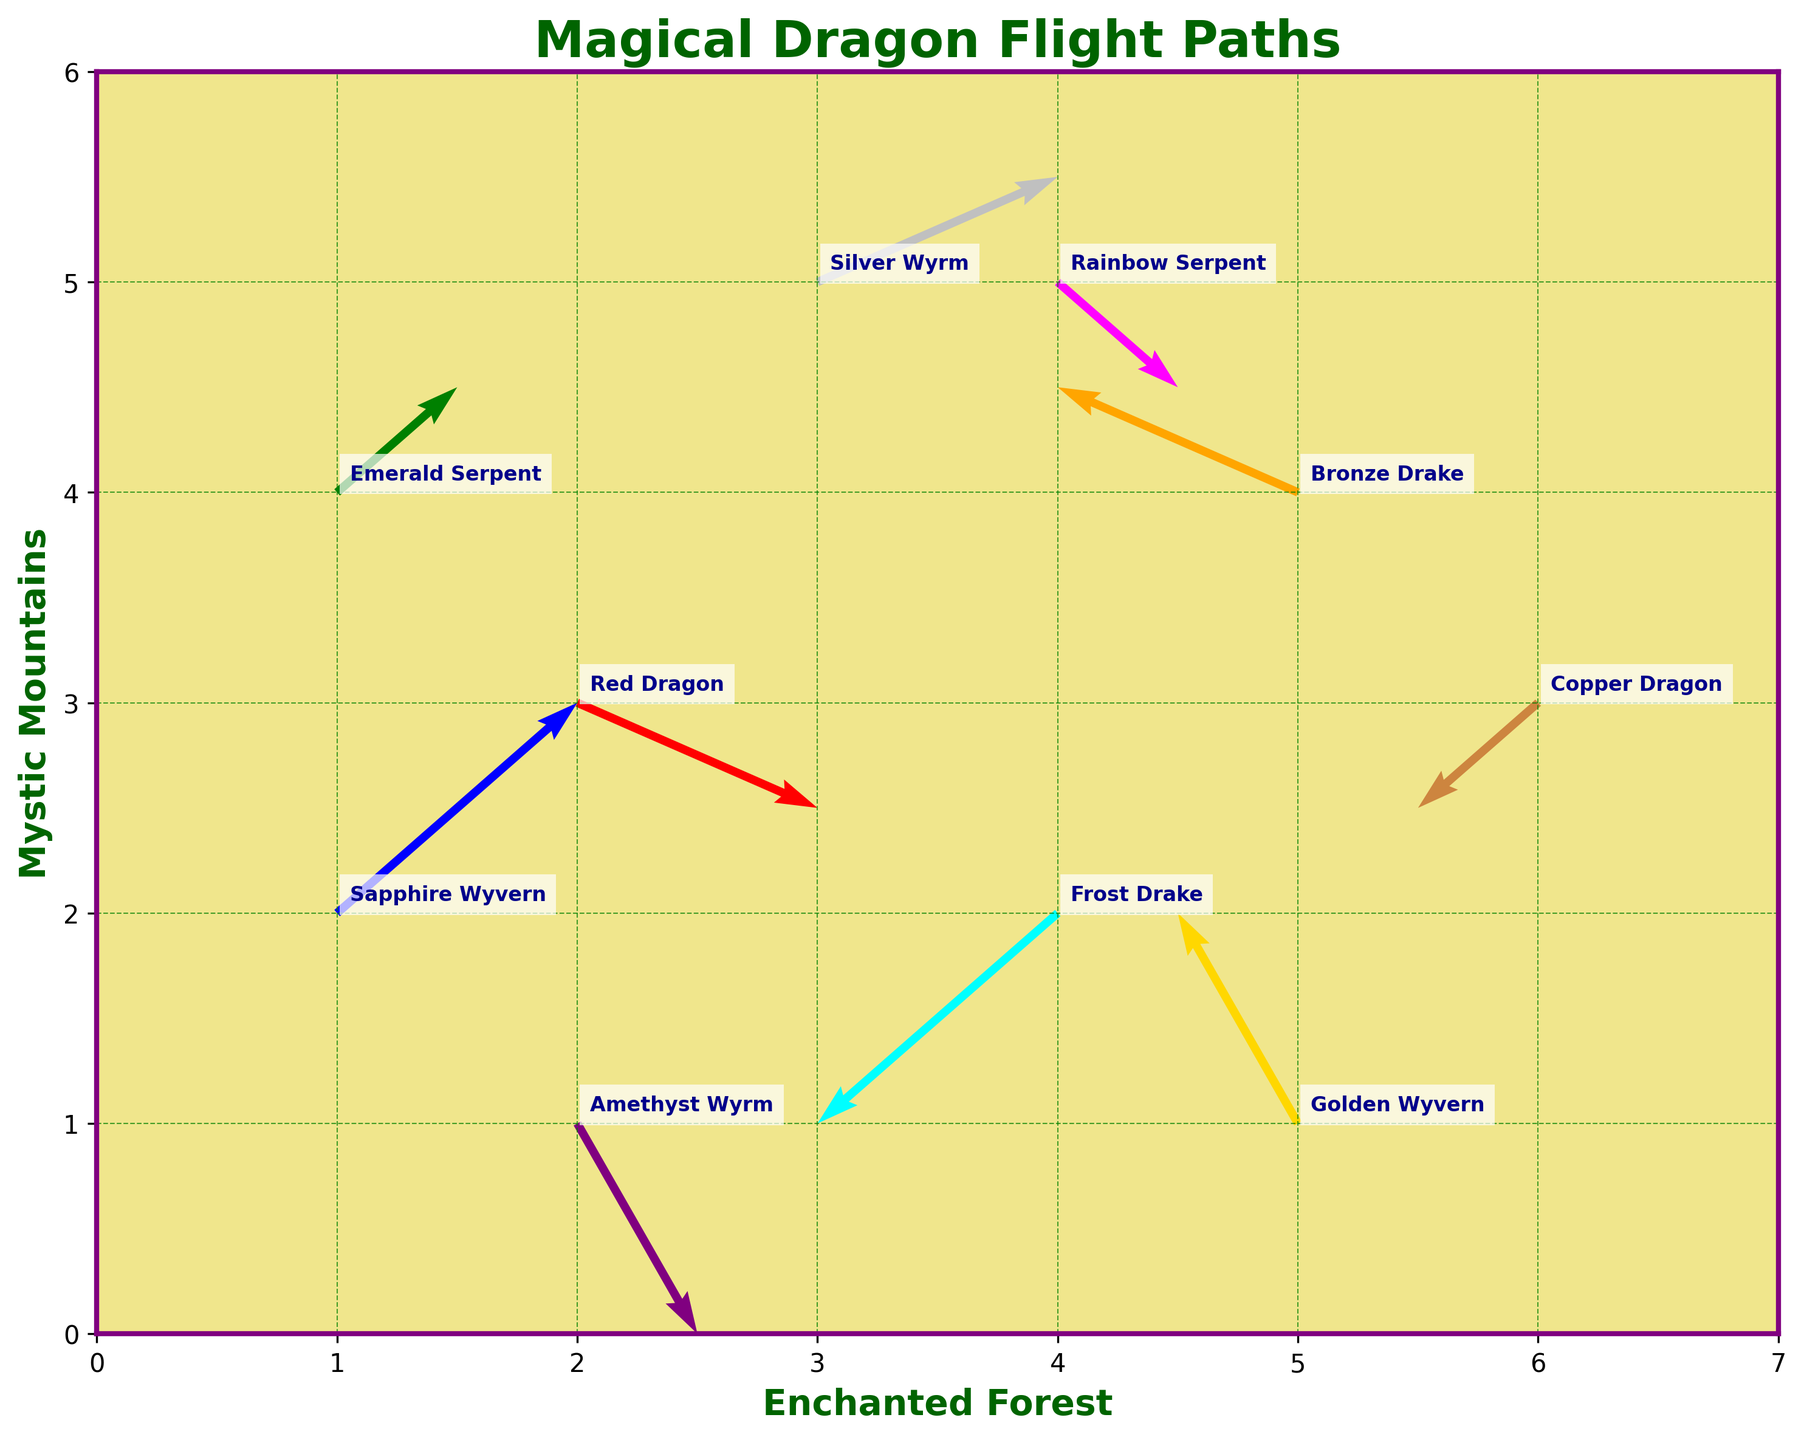What is the title of the figure? Look at the top of the figure. The title is usually displayed there.
Answer: Magical Dragon Flight Paths What is the background color of the plot? Observe the area behind the quiver arrows and annotations, which is uniformly colored.
Answer: Khaki Which dragon is positioned at (5,1)? Identify the dragon's names labeled at each coordinate on the plot.
Answer: Golden Wyvern How many dragons are shown in the plot? Count the number of unique names labeled on the plot.
Answer: 10 Which dragon has the longest flight path based on the arrows? Compare the lengths of the arrows representing each dragon's flight path.
Answer: Silver Wyrm Which dragon is flying directly south? Look for an arrow pointing downward vertically.
Answer: Amethyst Wyrm Which dragon's flight path starts at (4,2)? Find the coordinates (4,2) on the plot and identify the labeled dragon.
Answer: Frost Drake How many dragons are flying in a direction that has a downward component (negative y-direction)? Count the number of arrows that have a component pointing down.
Answer: 6 Is the Red Dragon flying more to the left or to the right? Observe the direction of the arrow originating from the Red Dragon's position.
Answer: Right Which dragon is closest to the Mystic Mountains' base (y-axis)? Identify the dragon with the smallest x-coordinate as it is closest to the y-axis.
Answer: Emerald Serpent 